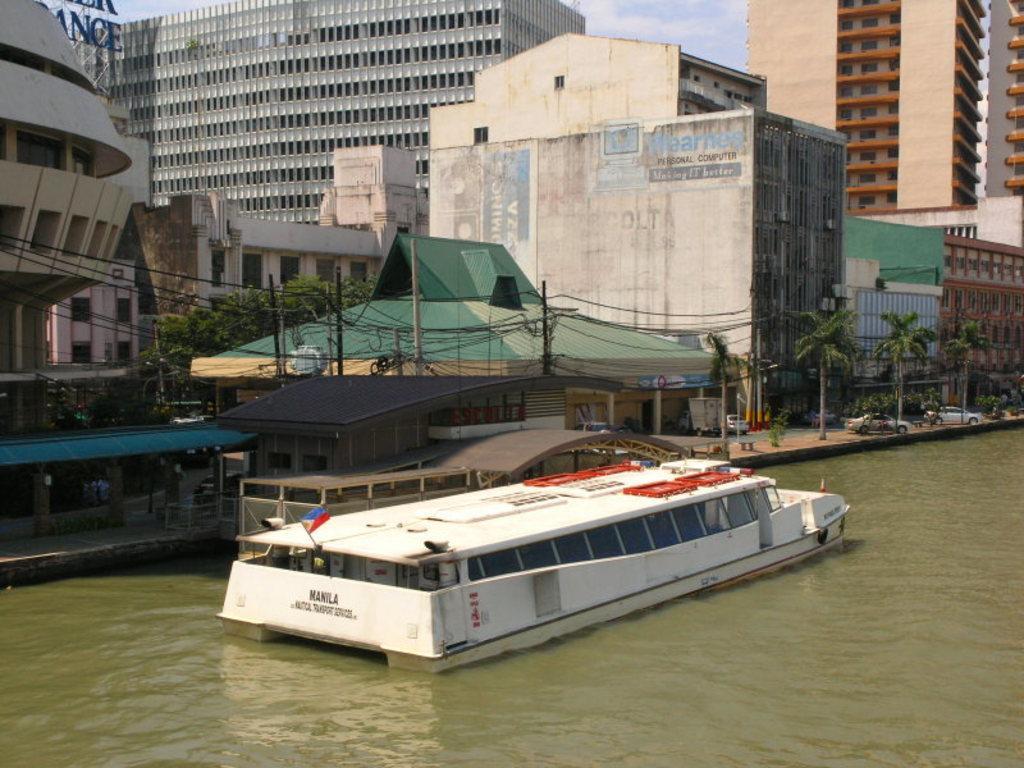In one or two sentences, can you explain what this image depicts? In this picture, we see a boat sailing in the water. Beside that, we see a building in green color and we even see cars parked on the road. Beside that, there are trees. In the background, there are trees. At the top of the picture, we see the sky. 